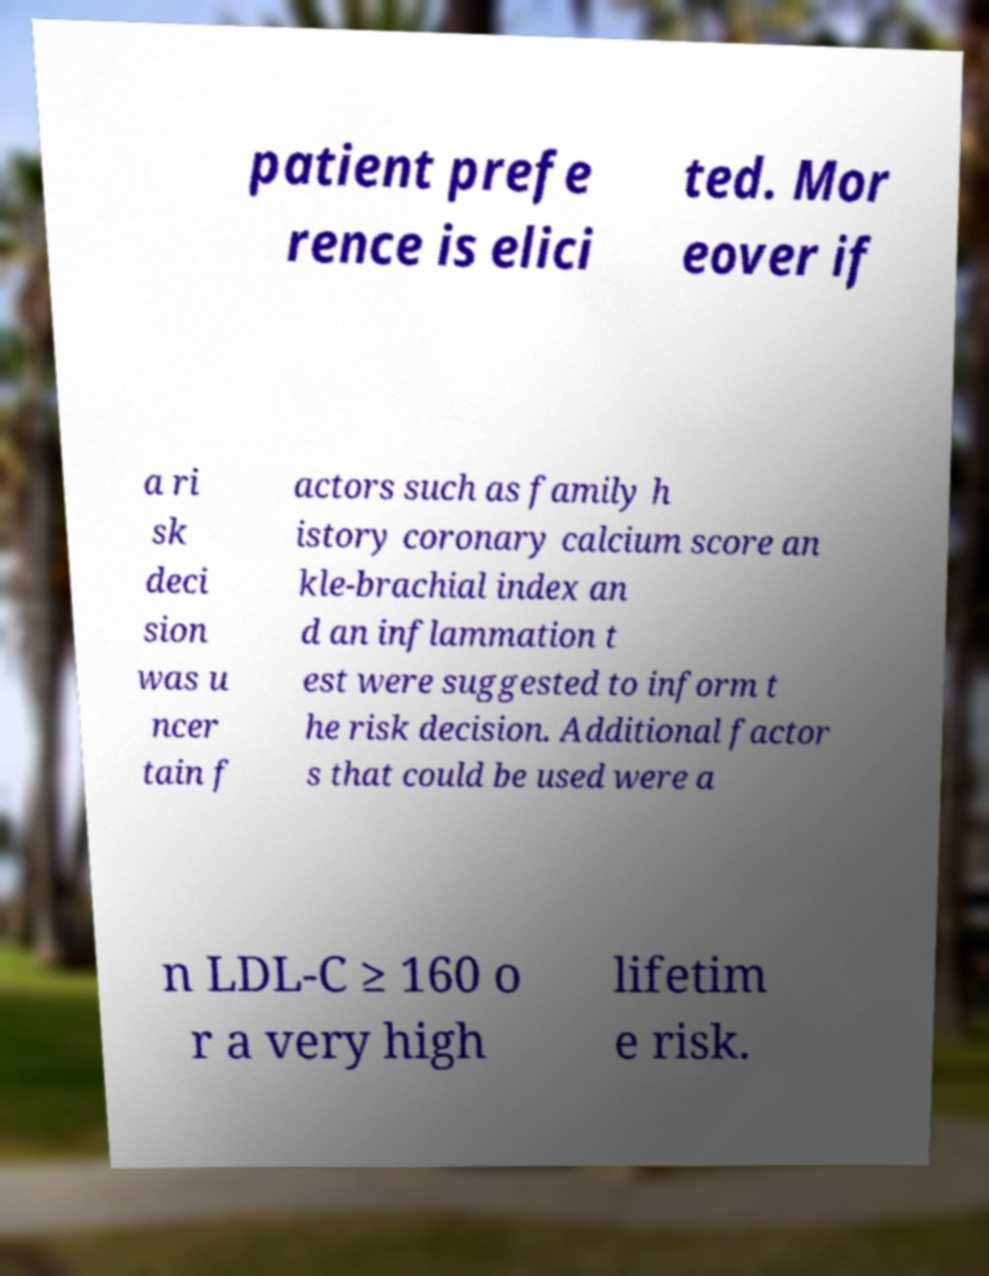I need the written content from this picture converted into text. Can you do that? patient prefe rence is elici ted. Mor eover if a ri sk deci sion was u ncer tain f actors such as family h istory coronary calcium score an kle-brachial index an d an inflammation t est were suggested to inform t he risk decision. Additional factor s that could be used were a n LDL-C ≥ 160 o r a very high lifetim e risk. 